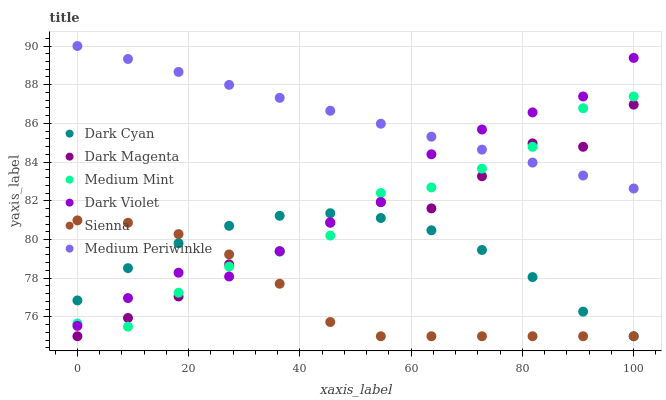Does Sienna have the minimum area under the curve?
Answer yes or no. Yes. Does Medium Periwinkle have the maximum area under the curve?
Answer yes or no. Yes. Does Dark Magenta have the minimum area under the curve?
Answer yes or no. No. Does Dark Magenta have the maximum area under the curve?
Answer yes or no. No. Is Medium Periwinkle the smoothest?
Answer yes or no. Yes. Is Dark Magenta the roughest?
Answer yes or no. Yes. Is Dark Magenta the smoothest?
Answer yes or no. No. Is Medium Periwinkle the roughest?
Answer yes or no. No. Does Dark Magenta have the lowest value?
Answer yes or no. Yes. Does Medium Periwinkle have the lowest value?
Answer yes or no. No. Does Medium Periwinkle have the highest value?
Answer yes or no. Yes. Does Dark Magenta have the highest value?
Answer yes or no. No. Is Sienna less than Medium Periwinkle?
Answer yes or no. Yes. Is Medium Periwinkle greater than Sienna?
Answer yes or no. Yes. Does Dark Magenta intersect Sienna?
Answer yes or no. Yes. Is Dark Magenta less than Sienna?
Answer yes or no. No. Is Dark Magenta greater than Sienna?
Answer yes or no. No. Does Sienna intersect Medium Periwinkle?
Answer yes or no. No. 